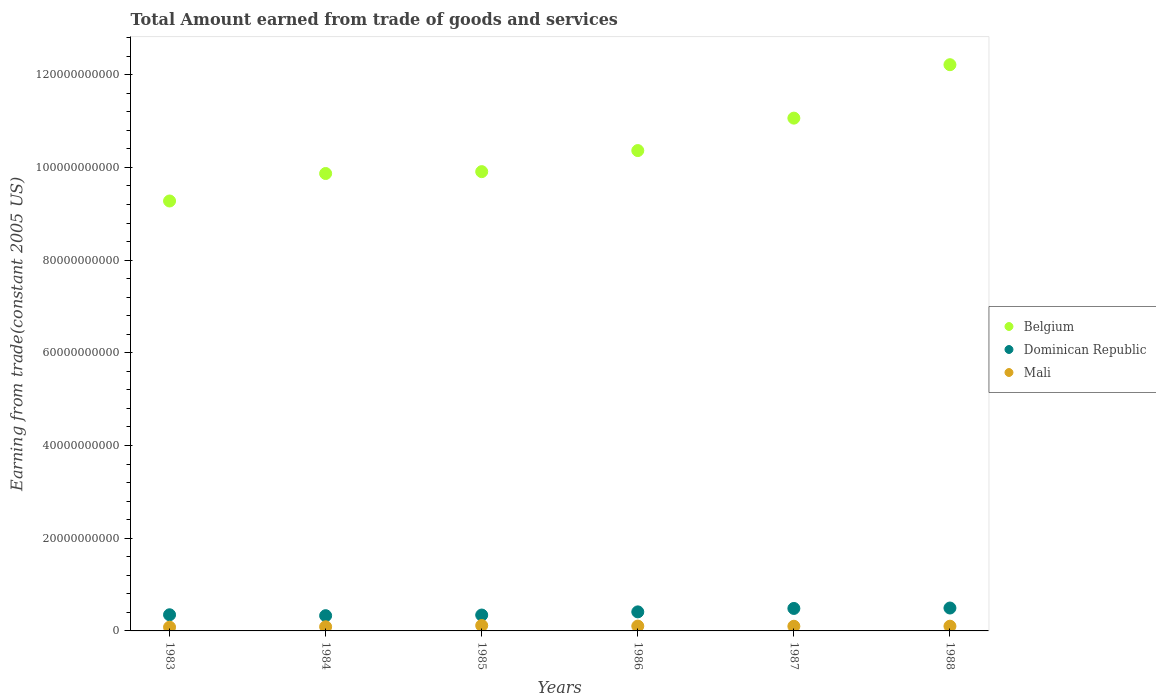What is the total amount earned by trading goods and services in Belgium in 1988?
Keep it short and to the point. 1.22e+11. Across all years, what is the maximum total amount earned by trading goods and services in Belgium?
Your response must be concise. 1.22e+11. Across all years, what is the minimum total amount earned by trading goods and services in Mali?
Your response must be concise. 8.09e+08. In which year was the total amount earned by trading goods and services in Mali minimum?
Give a very brief answer. 1983. What is the total total amount earned by trading goods and services in Belgium in the graph?
Your response must be concise. 6.27e+11. What is the difference between the total amount earned by trading goods and services in Belgium in 1985 and that in 1987?
Provide a short and direct response. -1.15e+1. What is the difference between the total amount earned by trading goods and services in Dominican Republic in 1984 and the total amount earned by trading goods and services in Mali in 1983?
Make the answer very short. 2.48e+09. What is the average total amount earned by trading goods and services in Belgium per year?
Offer a very short reply. 1.04e+11. In the year 1984, what is the difference between the total amount earned by trading goods and services in Dominican Republic and total amount earned by trading goods and services in Mali?
Keep it short and to the point. 2.39e+09. In how many years, is the total amount earned by trading goods and services in Belgium greater than 92000000000 US$?
Offer a very short reply. 6. What is the ratio of the total amount earned by trading goods and services in Dominican Republic in 1983 to that in 1986?
Ensure brevity in your answer.  0.85. What is the difference between the highest and the second highest total amount earned by trading goods and services in Dominican Republic?
Keep it short and to the point. 8.89e+07. What is the difference between the highest and the lowest total amount earned by trading goods and services in Dominican Republic?
Keep it short and to the point. 1.65e+09. Is the sum of the total amount earned by trading goods and services in Mali in 1985 and 1986 greater than the maximum total amount earned by trading goods and services in Belgium across all years?
Your answer should be compact. No. How many dotlines are there?
Your response must be concise. 3. How many years are there in the graph?
Offer a very short reply. 6. Are the values on the major ticks of Y-axis written in scientific E-notation?
Offer a terse response. No. Does the graph contain any zero values?
Make the answer very short. No. Where does the legend appear in the graph?
Ensure brevity in your answer.  Center right. How many legend labels are there?
Give a very brief answer. 3. What is the title of the graph?
Your response must be concise. Total Amount earned from trade of goods and services. What is the label or title of the X-axis?
Offer a terse response. Years. What is the label or title of the Y-axis?
Keep it short and to the point. Earning from trade(constant 2005 US). What is the Earning from trade(constant 2005 US) of Belgium in 1983?
Keep it short and to the point. 9.28e+1. What is the Earning from trade(constant 2005 US) of Dominican Republic in 1983?
Offer a terse response. 3.49e+09. What is the Earning from trade(constant 2005 US) of Mali in 1983?
Provide a short and direct response. 8.09e+08. What is the Earning from trade(constant 2005 US) of Belgium in 1984?
Your answer should be very brief. 9.87e+1. What is the Earning from trade(constant 2005 US) of Dominican Republic in 1984?
Your response must be concise. 3.29e+09. What is the Earning from trade(constant 2005 US) of Mali in 1984?
Make the answer very short. 8.95e+08. What is the Earning from trade(constant 2005 US) in Belgium in 1985?
Give a very brief answer. 9.91e+1. What is the Earning from trade(constant 2005 US) in Dominican Republic in 1985?
Ensure brevity in your answer.  3.43e+09. What is the Earning from trade(constant 2005 US) of Mali in 1985?
Make the answer very short. 1.17e+09. What is the Earning from trade(constant 2005 US) in Belgium in 1986?
Offer a very short reply. 1.04e+11. What is the Earning from trade(constant 2005 US) in Dominican Republic in 1986?
Your response must be concise. 4.11e+09. What is the Earning from trade(constant 2005 US) of Mali in 1986?
Offer a very short reply. 1.04e+09. What is the Earning from trade(constant 2005 US) of Belgium in 1987?
Offer a very short reply. 1.11e+11. What is the Earning from trade(constant 2005 US) in Dominican Republic in 1987?
Your answer should be compact. 4.85e+09. What is the Earning from trade(constant 2005 US) of Mali in 1987?
Your answer should be compact. 1.00e+09. What is the Earning from trade(constant 2005 US) in Belgium in 1988?
Keep it short and to the point. 1.22e+11. What is the Earning from trade(constant 2005 US) in Dominican Republic in 1988?
Keep it short and to the point. 4.94e+09. What is the Earning from trade(constant 2005 US) of Mali in 1988?
Ensure brevity in your answer.  1.02e+09. Across all years, what is the maximum Earning from trade(constant 2005 US) in Belgium?
Keep it short and to the point. 1.22e+11. Across all years, what is the maximum Earning from trade(constant 2005 US) in Dominican Republic?
Provide a short and direct response. 4.94e+09. Across all years, what is the maximum Earning from trade(constant 2005 US) of Mali?
Offer a very short reply. 1.17e+09. Across all years, what is the minimum Earning from trade(constant 2005 US) in Belgium?
Make the answer very short. 9.28e+1. Across all years, what is the minimum Earning from trade(constant 2005 US) in Dominican Republic?
Provide a short and direct response. 3.29e+09. Across all years, what is the minimum Earning from trade(constant 2005 US) of Mali?
Ensure brevity in your answer.  8.09e+08. What is the total Earning from trade(constant 2005 US) in Belgium in the graph?
Ensure brevity in your answer.  6.27e+11. What is the total Earning from trade(constant 2005 US) of Dominican Republic in the graph?
Your answer should be very brief. 2.41e+1. What is the total Earning from trade(constant 2005 US) of Mali in the graph?
Give a very brief answer. 5.94e+09. What is the difference between the Earning from trade(constant 2005 US) in Belgium in 1983 and that in 1984?
Make the answer very short. -5.93e+09. What is the difference between the Earning from trade(constant 2005 US) in Dominican Republic in 1983 and that in 1984?
Your response must be concise. 1.96e+08. What is the difference between the Earning from trade(constant 2005 US) of Mali in 1983 and that in 1984?
Your response must be concise. -8.58e+07. What is the difference between the Earning from trade(constant 2005 US) in Belgium in 1983 and that in 1985?
Provide a short and direct response. -6.33e+09. What is the difference between the Earning from trade(constant 2005 US) of Dominican Republic in 1983 and that in 1985?
Your answer should be compact. 5.93e+07. What is the difference between the Earning from trade(constant 2005 US) in Mali in 1983 and that in 1985?
Your response must be concise. -3.59e+08. What is the difference between the Earning from trade(constant 2005 US) of Belgium in 1983 and that in 1986?
Keep it short and to the point. -1.09e+1. What is the difference between the Earning from trade(constant 2005 US) of Dominican Republic in 1983 and that in 1986?
Give a very brief answer. -6.24e+08. What is the difference between the Earning from trade(constant 2005 US) of Mali in 1983 and that in 1986?
Ensure brevity in your answer.  -2.36e+08. What is the difference between the Earning from trade(constant 2005 US) of Belgium in 1983 and that in 1987?
Provide a short and direct response. -1.79e+1. What is the difference between the Earning from trade(constant 2005 US) in Dominican Republic in 1983 and that in 1987?
Give a very brief answer. -1.36e+09. What is the difference between the Earning from trade(constant 2005 US) of Mali in 1983 and that in 1987?
Ensure brevity in your answer.  -1.94e+08. What is the difference between the Earning from trade(constant 2005 US) in Belgium in 1983 and that in 1988?
Keep it short and to the point. -2.94e+1. What is the difference between the Earning from trade(constant 2005 US) of Dominican Republic in 1983 and that in 1988?
Ensure brevity in your answer.  -1.45e+09. What is the difference between the Earning from trade(constant 2005 US) of Mali in 1983 and that in 1988?
Your response must be concise. -2.11e+08. What is the difference between the Earning from trade(constant 2005 US) in Belgium in 1984 and that in 1985?
Your answer should be compact. -4.02e+08. What is the difference between the Earning from trade(constant 2005 US) of Dominican Republic in 1984 and that in 1985?
Offer a terse response. -1.37e+08. What is the difference between the Earning from trade(constant 2005 US) in Mali in 1984 and that in 1985?
Your answer should be compact. -2.73e+08. What is the difference between the Earning from trade(constant 2005 US) in Belgium in 1984 and that in 1986?
Your answer should be compact. -4.95e+09. What is the difference between the Earning from trade(constant 2005 US) of Dominican Republic in 1984 and that in 1986?
Provide a succinct answer. -8.20e+08. What is the difference between the Earning from trade(constant 2005 US) of Mali in 1984 and that in 1986?
Ensure brevity in your answer.  -1.50e+08. What is the difference between the Earning from trade(constant 2005 US) in Belgium in 1984 and that in 1987?
Provide a short and direct response. -1.19e+1. What is the difference between the Earning from trade(constant 2005 US) in Dominican Republic in 1984 and that in 1987?
Give a very brief answer. -1.56e+09. What is the difference between the Earning from trade(constant 2005 US) of Mali in 1984 and that in 1987?
Give a very brief answer. -1.09e+08. What is the difference between the Earning from trade(constant 2005 US) of Belgium in 1984 and that in 1988?
Keep it short and to the point. -2.35e+1. What is the difference between the Earning from trade(constant 2005 US) of Dominican Republic in 1984 and that in 1988?
Ensure brevity in your answer.  -1.65e+09. What is the difference between the Earning from trade(constant 2005 US) in Mali in 1984 and that in 1988?
Offer a very short reply. -1.25e+08. What is the difference between the Earning from trade(constant 2005 US) in Belgium in 1985 and that in 1986?
Provide a short and direct response. -4.55e+09. What is the difference between the Earning from trade(constant 2005 US) of Dominican Republic in 1985 and that in 1986?
Your response must be concise. -6.84e+08. What is the difference between the Earning from trade(constant 2005 US) of Mali in 1985 and that in 1986?
Keep it short and to the point. 1.23e+08. What is the difference between the Earning from trade(constant 2005 US) in Belgium in 1985 and that in 1987?
Give a very brief answer. -1.15e+1. What is the difference between the Earning from trade(constant 2005 US) of Dominican Republic in 1985 and that in 1987?
Give a very brief answer. -1.42e+09. What is the difference between the Earning from trade(constant 2005 US) in Mali in 1985 and that in 1987?
Your response must be concise. 1.64e+08. What is the difference between the Earning from trade(constant 2005 US) in Belgium in 1985 and that in 1988?
Offer a very short reply. -2.31e+1. What is the difference between the Earning from trade(constant 2005 US) in Dominican Republic in 1985 and that in 1988?
Give a very brief answer. -1.51e+09. What is the difference between the Earning from trade(constant 2005 US) of Mali in 1985 and that in 1988?
Give a very brief answer. 1.48e+08. What is the difference between the Earning from trade(constant 2005 US) in Belgium in 1986 and that in 1987?
Give a very brief answer. -7.00e+09. What is the difference between the Earning from trade(constant 2005 US) in Dominican Republic in 1986 and that in 1987?
Give a very brief answer. -7.41e+08. What is the difference between the Earning from trade(constant 2005 US) in Mali in 1986 and that in 1987?
Make the answer very short. 4.13e+07. What is the difference between the Earning from trade(constant 2005 US) in Belgium in 1986 and that in 1988?
Offer a terse response. -1.85e+1. What is the difference between the Earning from trade(constant 2005 US) of Dominican Republic in 1986 and that in 1988?
Offer a terse response. -8.30e+08. What is the difference between the Earning from trade(constant 2005 US) in Mali in 1986 and that in 1988?
Your answer should be compact. 2.50e+07. What is the difference between the Earning from trade(constant 2005 US) of Belgium in 1987 and that in 1988?
Your answer should be very brief. -1.15e+1. What is the difference between the Earning from trade(constant 2005 US) in Dominican Republic in 1987 and that in 1988?
Keep it short and to the point. -8.89e+07. What is the difference between the Earning from trade(constant 2005 US) in Mali in 1987 and that in 1988?
Offer a very short reply. -1.64e+07. What is the difference between the Earning from trade(constant 2005 US) of Belgium in 1983 and the Earning from trade(constant 2005 US) of Dominican Republic in 1984?
Your response must be concise. 8.95e+1. What is the difference between the Earning from trade(constant 2005 US) in Belgium in 1983 and the Earning from trade(constant 2005 US) in Mali in 1984?
Keep it short and to the point. 9.19e+1. What is the difference between the Earning from trade(constant 2005 US) of Dominican Republic in 1983 and the Earning from trade(constant 2005 US) of Mali in 1984?
Your response must be concise. 2.59e+09. What is the difference between the Earning from trade(constant 2005 US) of Belgium in 1983 and the Earning from trade(constant 2005 US) of Dominican Republic in 1985?
Your response must be concise. 8.93e+1. What is the difference between the Earning from trade(constant 2005 US) in Belgium in 1983 and the Earning from trade(constant 2005 US) in Mali in 1985?
Your answer should be compact. 9.16e+1. What is the difference between the Earning from trade(constant 2005 US) in Dominican Republic in 1983 and the Earning from trade(constant 2005 US) in Mali in 1985?
Provide a succinct answer. 2.32e+09. What is the difference between the Earning from trade(constant 2005 US) of Belgium in 1983 and the Earning from trade(constant 2005 US) of Dominican Republic in 1986?
Provide a succinct answer. 8.87e+1. What is the difference between the Earning from trade(constant 2005 US) in Belgium in 1983 and the Earning from trade(constant 2005 US) in Mali in 1986?
Offer a very short reply. 9.17e+1. What is the difference between the Earning from trade(constant 2005 US) of Dominican Republic in 1983 and the Earning from trade(constant 2005 US) of Mali in 1986?
Make the answer very short. 2.44e+09. What is the difference between the Earning from trade(constant 2005 US) of Belgium in 1983 and the Earning from trade(constant 2005 US) of Dominican Republic in 1987?
Provide a succinct answer. 8.79e+1. What is the difference between the Earning from trade(constant 2005 US) of Belgium in 1983 and the Earning from trade(constant 2005 US) of Mali in 1987?
Provide a succinct answer. 9.18e+1. What is the difference between the Earning from trade(constant 2005 US) of Dominican Republic in 1983 and the Earning from trade(constant 2005 US) of Mali in 1987?
Keep it short and to the point. 2.48e+09. What is the difference between the Earning from trade(constant 2005 US) of Belgium in 1983 and the Earning from trade(constant 2005 US) of Dominican Republic in 1988?
Provide a short and direct response. 8.78e+1. What is the difference between the Earning from trade(constant 2005 US) in Belgium in 1983 and the Earning from trade(constant 2005 US) in Mali in 1988?
Keep it short and to the point. 9.17e+1. What is the difference between the Earning from trade(constant 2005 US) of Dominican Republic in 1983 and the Earning from trade(constant 2005 US) of Mali in 1988?
Ensure brevity in your answer.  2.47e+09. What is the difference between the Earning from trade(constant 2005 US) of Belgium in 1984 and the Earning from trade(constant 2005 US) of Dominican Republic in 1985?
Provide a succinct answer. 9.53e+1. What is the difference between the Earning from trade(constant 2005 US) of Belgium in 1984 and the Earning from trade(constant 2005 US) of Mali in 1985?
Offer a very short reply. 9.75e+1. What is the difference between the Earning from trade(constant 2005 US) of Dominican Republic in 1984 and the Earning from trade(constant 2005 US) of Mali in 1985?
Provide a succinct answer. 2.12e+09. What is the difference between the Earning from trade(constant 2005 US) in Belgium in 1984 and the Earning from trade(constant 2005 US) in Dominican Republic in 1986?
Provide a short and direct response. 9.46e+1. What is the difference between the Earning from trade(constant 2005 US) of Belgium in 1984 and the Earning from trade(constant 2005 US) of Mali in 1986?
Give a very brief answer. 9.76e+1. What is the difference between the Earning from trade(constant 2005 US) of Dominican Republic in 1984 and the Earning from trade(constant 2005 US) of Mali in 1986?
Your answer should be very brief. 2.24e+09. What is the difference between the Earning from trade(constant 2005 US) in Belgium in 1984 and the Earning from trade(constant 2005 US) in Dominican Republic in 1987?
Provide a short and direct response. 9.38e+1. What is the difference between the Earning from trade(constant 2005 US) in Belgium in 1984 and the Earning from trade(constant 2005 US) in Mali in 1987?
Your answer should be very brief. 9.77e+1. What is the difference between the Earning from trade(constant 2005 US) of Dominican Republic in 1984 and the Earning from trade(constant 2005 US) of Mali in 1987?
Make the answer very short. 2.29e+09. What is the difference between the Earning from trade(constant 2005 US) in Belgium in 1984 and the Earning from trade(constant 2005 US) in Dominican Republic in 1988?
Provide a short and direct response. 9.38e+1. What is the difference between the Earning from trade(constant 2005 US) of Belgium in 1984 and the Earning from trade(constant 2005 US) of Mali in 1988?
Keep it short and to the point. 9.77e+1. What is the difference between the Earning from trade(constant 2005 US) in Dominican Republic in 1984 and the Earning from trade(constant 2005 US) in Mali in 1988?
Ensure brevity in your answer.  2.27e+09. What is the difference between the Earning from trade(constant 2005 US) of Belgium in 1985 and the Earning from trade(constant 2005 US) of Dominican Republic in 1986?
Offer a very short reply. 9.50e+1. What is the difference between the Earning from trade(constant 2005 US) in Belgium in 1985 and the Earning from trade(constant 2005 US) in Mali in 1986?
Provide a succinct answer. 9.80e+1. What is the difference between the Earning from trade(constant 2005 US) in Dominican Republic in 1985 and the Earning from trade(constant 2005 US) in Mali in 1986?
Make the answer very short. 2.38e+09. What is the difference between the Earning from trade(constant 2005 US) of Belgium in 1985 and the Earning from trade(constant 2005 US) of Dominican Republic in 1987?
Your response must be concise. 9.42e+1. What is the difference between the Earning from trade(constant 2005 US) in Belgium in 1985 and the Earning from trade(constant 2005 US) in Mali in 1987?
Offer a very short reply. 9.81e+1. What is the difference between the Earning from trade(constant 2005 US) in Dominican Republic in 1985 and the Earning from trade(constant 2005 US) in Mali in 1987?
Provide a succinct answer. 2.42e+09. What is the difference between the Earning from trade(constant 2005 US) of Belgium in 1985 and the Earning from trade(constant 2005 US) of Dominican Republic in 1988?
Offer a terse response. 9.42e+1. What is the difference between the Earning from trade(constant 2005 US) in Belgium in 1985 and the Earning from trade(constant 2005 US) in Mali in 1988?
Your answer should be very brief. 9.81e+1. What is the difference between the Earning from trade(constant 2005 US) of Dominican Republic in 1985 and the Earning from trade(constant 2005 US) of Mali in 1988?
Your response must be concise. 2.41e+09. What is the difference between the Earning from trade(constant 2005 US) of Belgium in 1986 and the Earning from trade(constant 2005 US) of Dominican Republic in 1987?
Keep it short and to the point. 9.88e+1. What is the difference between the Earning from trade(constant 2005 US) of Belgium in 1986 and the Earning from trade(constant 2005 US) of Mali in 1987?
Make the answer very short. 1.03e+11. What is the difference between the Earning from trade(constant 2005 US) in Dominican Republic in 1986 and the Earning from trade(constant 2005 US) in Mali in 1987?
Keep it short and to the point. 3.11e+09. What is the difference between the Earning from trade(constant 2005 US) in Belgium in 1986 and the Earning from trade(constant 2005 US) in Dominican Republic in 1988?
Ensure brevity in your answer.  9.87e+1. What is the difference between the Earning from trade(constant 2005 US) of Belgium in 1986 and the Earning from trade(constant 2005 US) of Mali in 1988?
Ensure brevity in your answer.  1.03e+11. What is the difference between the Earning from trade(constant 2005 US) of Dominican Republic in 1986 and the Earning from trade(constant 2005 US) of Mali in 1988?
Give a very brief answer. 3.09e+09. What is the difference between the Earning from trade(constant 2005 US) in Belgium in 1987 and the Earning from trade(constant 2005 US) in Dominican Republic in 1988?
Offer a terse response. 1.06e+11. What is the difference between the Earning from trade(constant 2005 US) of Belgium in 1987 and the Earning from trade(constant 2005 US) of Mali in 1988?
Ensure brevity in your answer.  1.10e+11. What is the difference between the Earning from trade(constant 2005 US) of Dominican Republic in 1987 and the Earning from trade(constant 2005 US) of Mali in 1988?
Your answer should be compact. 3.83e+09. What is the average Earning from trade(constant 2005 US) of Belgium per year?
Provide a succinct answer. 1.04e+11. What is the average Earning from trade(constant 2005 US) in Dominican Republic per year?
Keep it short and to the point. 4.02e+09. What is the average Earning from trade(constant 2005 US) of Mali per year?
Provide a succinct answer. 9.90e+08. In the year 1983, what is the difference between the Earning from trade(constant 2005 US) of Belgium and Earning from trade(constant 2005 US) of Dominican Republic?
Ensure brevity in your answer.  8.93e+1. In the year 1983, what is the difference between the Earning from trade(constant 2005 US) of Belgium and Earning from trade(constant 2005 US) of Mali?
Make the answer very short. 9.20e+1. In the year 1983, what is the difference between the Earning from trade(constant 2005 US) in Dominican Republic and Earning from trade(constant 2005 US) in Mali?
Keep it short and to the point. 2.68e+09. In the year 1984, what is the difference between the Earning from trade(constant 2005 US) of Belgium and Earning from trade(constant 2005 US) of Dominican Republic?
Your answer should be very brief. 9.54e+1. In the year 1984, what is the difference between the Earning from trade(constant 2005 US) in Belgium and Earning from trade(constant 2005 US) in Mali?
Your answer should be compact. 9.78e+1. In the year 1984, what is the difference between the Earning from trade(constant 2005 US) in Dominican Republic and Earning from trade(constant 2005 US) in Mali?
Provide a short and direct response. 2.39e+09. In the year 1985, what is the difference between the Earning from trade(constant 2005 US) of Belgium and Earning from trade(constant 2005 US) of Dominican Republic?
Your answer should be very brief. 9.57e+1. In the year 1985, what is the difference between the Earning from trade(constant 2005 US) in Belgium and Earning from trade(constant 2005 US) in Mali?
Give a very brief answer. 9.79e+1. In the year 1985, what is the difference between the Earning from trade(constant 2005 US) in Dominican Republic and Earning from trade(constant 2005 US) in Mali?
Offer a terse response. 2.26e+09. In the year 1986, what is the difference between the Earning from trade(constant 2005 US) in Belgium and Earning from trade(constant 2005 US) in Dominican Republic?
Your response must be concise. 9.95e+1. In the year 1986, what is the difference between the Earning from trade(constant 2005 US) in Belgium and Earning from trade(constant 2005 US) in Mali?
Give a very brief answer. 1.03e+11. In the year 1986, what is the difference between the Earning from trade(constant 2005 US) in Dominican Republic and Earning from trade(constant 2005 US) in Mali?
Give a very brief answer. 3.07e+09. In the year 1987, what is the difference between the Earning from trade(constant 2005 US) of Belgium and Earning from trade(constant 2005 US) of Dominican Republic?
Your response must be concise. 1.06e+11. In the year 1987, what is the difference between the Earning from trade(constant 2005 US) in Belgium and Earning from trade(constant 2005 US) in Mali?
Offer a terse response. 1.10e+11. In the year 1987, what is the difference between the Earning from trade(constant 2005 US) in Dominican Republic and Earning from trade(constant 2005 US) in Mali?
Provide a short and direct response. 3.85e+09. In the year 1988, what is the difference between the Earning from trade(constant 2005 US) in Belgium and Earning from trade(constant 2005 US) in Dominican Republic?
Your answer should be very brief. 1.17e+11. In the year 1988, what is the difference between the Earning from trade(constant 2005 US) of Belgium and Earning from trade(constant 2005 US) of Mali?
Offer a very short reply. 1.21e+11. In the year 1988, what is the difference between the Earning from trade(constant 2005 US) in Dominican Republic and Earning from trade(constant 2005 US) in Mali?
Provide a short and direct response. 3.92e+09. What is the ratio of the Earning from trade(constant 2005 US) of Belgium in 1983 to that in 1984?
Your answer should be compact. 0.94. What is the ratio of the Earning from trade(constant 2005 US) of Dominican Republic in 1983 to that in 1984?
Make the answer very short. 1.06. What is the ratio of the Earning from trade(constant 2005 US) in Mali in 1983 to that in 1984?
Make the answer very short. 0.9. What is the ratio of the Earning from trade(constant 2005 US) of Belgium in 1983 to that in 1985?
Offer a terse response. 0.94. What is the ratio of the Earning from trade(constant 2005 US) of Dominican Republic in 1983 to that in 1985?
Offer a terse response. 1.02. What is the ratio of the Earning from trade(constant 2005 US) in Mali in 1983 to that in 1985?
Provide a short and direct response. 0.69. What is the ratio of the Earning from trade(constant 2005 US) in Belgium in 1983 to that in 1986?
Offer a terse response. 0.9. What is the ratio of the Earning from trade(constant 2005 US) of Dominican Republic in 1983 to that in 1986?
Keep it short and to the point. 0.85. What is the ratio of the Earning from trade(constant 2005 US) in Mali in 1983 to that in 1986?
Offer a very short reply. 0.77. What is the ratio of the Earning from trade(constant 2005 US) of Belgium in 1983 to that in 1987?
Keep it short and to the point. 0.84. What is the ratio of the Earning from trade(constant 2005 US) of Dominican Republic in 1983 to that in 1987?
Your response must be concise. 0.72. What is the ratio of the Earning from trade(constant 2005 US) of Mali in 1983 to that in 1987?
Make the answer very short. 0.81. What is the ratio of the Earning from trade(constant 2005 US) of Belgium in 1983 to that in 1988?
Provide a short and direct response. 0.76. What is the ratio of the Earning from trade(constant 2005 US) in Dominican Republic in 1983 to that in 1988?
Offer a terse response. 0.71. What is the ratio of the Earning from trade(constant 2005 US) in Mali in 1983 to that in 1988?
Your response must be concise. 0.79. What is the ratio of the Earning from trade(constant 2005 US) of Dominican Republic in 1984 to that in 1985?
Keep it short and to the point. 0.96. What is the ratio of the Earning from trade(constant 2005 US) in Mali in 1984 to that in 1985?
Your answer should be compact. 0.77. What is the ratio of the Earning from trade(constant 2005 US) in Belgium in 1984 to that in 1986?
Your answer should be very brief. 0.95. What is the ratio of the Earning from trade(constant 2005 US) of Dominican Republic in 1984 to that in 1986?
Your response must be concise. 0.8. What is the ratio of the Earning from trade(constant 2005 US) of Mali in 1984 to that in 1986?
Provide a succinct answer. 0.86. What is the ratio of the Earning from trade(constant 2005 US) of Belgium in 1984 to that in 1987?
Your answer should be compact. 0.89. What is the ratio of the Earning from trade(constant 2005 US) in Dominican Republic in 1984 to that in 1987?
Make the answer very short. 0.68. What is the ratio of the Earning from trade(constant 2005 US) of Mali in 1984 to that in 1987?
Offer a very short reply. 0.89. What is the ratio of the Earning from trade(constant 2005 US) of Belgium in 1984 to that in 1988?
Your answer should be very brief. 0.81. What is the ratio of the Earning from trade(constant 2005 US) of Dominican Republic in 1984 to that in 1988?
Make the answer very short. 0.67. What is the ratio of the Earning from trade(constant 2005 US) of Mali in 1984 to that in 1988?
Make the answer very short. 0.88. What is the ratio of the Earning from trade(constant 2005 US) in Belgium in 1985 to that in 1986?
Your answer should be compact. 0.96. What is the ratio of the Earning from trade(constant 2005 US) of Dominican Republic in 1985 to that in 1986?
Give a very brief answer. 0.83. What is the ratio of the Earning from trade(constant 2005 US) in Mali in 1985 to that in 1986?
Make the answer very short. 1.12. What is the ratio of the Earning from trade(constant 2005 US) of Belgium in 1985 to that in 1987?
Offer a very short reply. 0.9. What is the ratio of the Earning from trade(constant 2005 US) of Dominican Republic in 1985 to that in 1987?
Your response must be concise. 0.71. What is the ratio of the Earning from trade(constant 2005 US) in Mali in 1985 to that in 1987?
Your answer should be very brief. 1.16. What is the ratio of the Earning from trade(constant 2005 US) of Belgium in 1985 to that in 1988?
Make the answer very short. 0.81. What is the ratio of the Earning from trade(constant 2005 US) in Dominican Republic in 1985 to that in 1988?
Your response must be concise. 0.69. What is the ratio of the Earning from trade(constant 2005 US) of Mali in 1985 to that in 1988?
Offer a terse response. 1.15. What is the ratio of the Earning from trade(constant 2005 US) in Belgium in 1986 to that in 1987?
Provide a succinct answer. 0.94. What is the ratio of the Earning from trade(constant 2005 US) of Dominican Republic in 1986 to that in 1987?
Keep it short and to the point. 0.85. What is the ratio of the Earning from trade(constant 2005 US) of Mali in 1986 to that in 1987?
Offer a very short reply. 1.04. What is the ratio of the Earning from trade(constant 2005 US) of Belgium in 1986 to that in 1988?
Your response must be concise. 0.85. What is the ratio of the Earning from trade(constant 2005 US) of Dominican Republic in 1986 to that in 1988?
Offer a terse response. 0.83. What is the ratio of the Earning from trade(constant 2005 US) in Mali in 1986 to that in 1988?
Offer a very short reply. 1.02. What is the ratio of the Earning from trade(constant 2005 US) of Belgium in 1987 to that in 1988?
Provide a succinct answer. 0.91. What is the ratio of the Earning from trade(constant 2005 US) of Mali in 1987 to that in 1988?
Provide a short and direct response. 0.98. What is the difference between the highest and the second highest Earning from trade(constant 2005 US) in Belgium?
Offer a very short reply. 1.15e+1. What is the difference between the highest and the second highest Earning from trade(constant 2005 US) of Dominican Republic?
Keep it short and to the point. 8.89e+07. What is the difference between the highest and the second highest Earning from trade(constant 2005 US) of Mali?
Your response must be concise. 1.23e+08. What is the difference between the highest and the lowest Earning from trade(constant 2005 US) in Belgium?
Offer a terse response. 2.94e+1. What is the difference between the highest and the lowest Earning from trade(constant 2005 US) in Dominican Republic?
Provide a succinct answer. 1.65e+09. What is the difference between the highest and the lowest Earning from trade(constant 2005 US) of Mali?
Your answer should be very brief. 3.59e+08. 